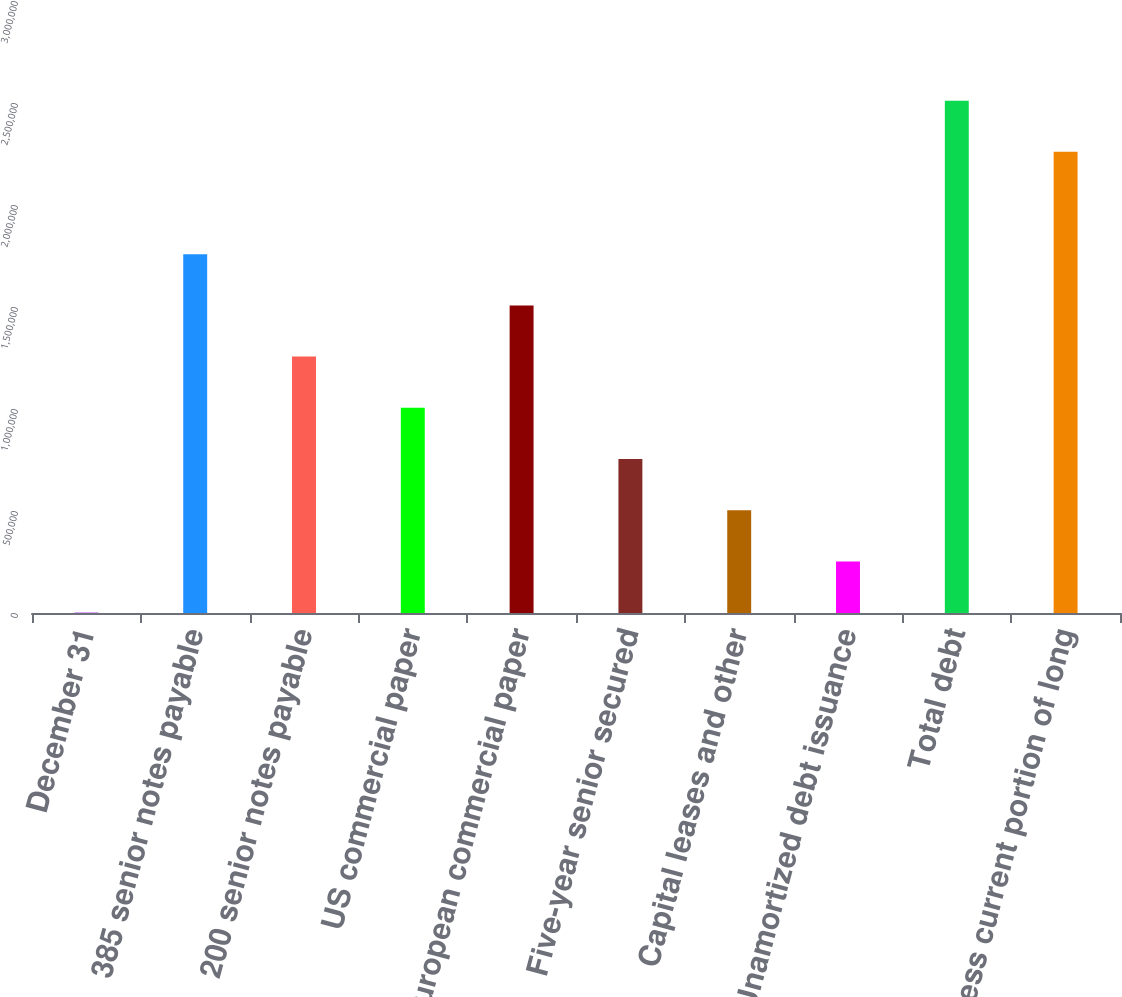Convert chart. <chart><loc_0><loc_0><loc_500><loc_500><bar_chart><fcel>December 31<fcel>385 senior notes payable<fcel>200 senior notes payable<fcel>US commercial paper<fcel>European commercial paper<fcel>Five-year senior secured<fcel>Capital leases and other<fcel>Unamortized debt issuance<fcel>Total debt<fcel>Less current portion of long<nl><fcel>2016<fcel>1.75864e+06<fcel>1.25675e+06<fcel>1.0058e+06<fcel>1.5077e+06<fcel>754857<fcel>503910<fcel>252963<fcel>2.51148e+06<fcel>2.26054e+06<nl></chart> 